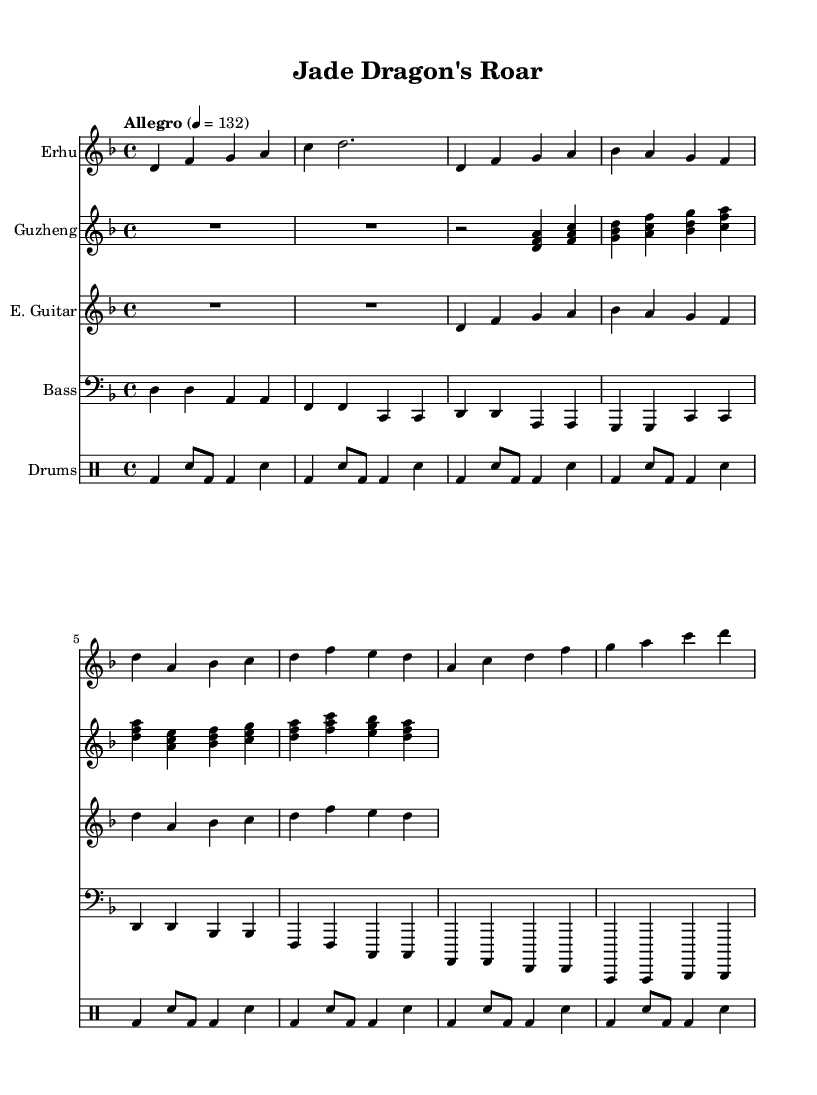What is the key signature of this music? The key signature is D minor, which has one flat (B flat). This can be determined by looking at the key signature indicated at the beginning of the score.
Answer: D minor What is the time signature of the piece? The time signature is 4/4, which is commonly noted at the beginning of the score indicating four beats per measure with a quarter note receiving one beat. This is found prominently in the initial section of the music.
Answer: 4/4 What is the tempo marking for the piece? The tempo marking is Allegro, which is indicated in the tempo indication at the start of the score, showing a fast and lively pace. The beats per minute is set at 132.
Answer: Allegro How many bars are present in the electric guitar section? In the electric guitar section, there are 8 bars, counted by noting each measure line and taking into account the rest measures as well.
Answer: 8 Which traditional Chinese instrument is featured throughout this score? The traditional Chinese instrument featured is the Erhu, which is specified at the start of its staff. Its role is significant in the arrangement, blending with modern rock elements.
Answer: Erhu What is the rhythmic pattern in the drum kit section? The rhythmic pattern in the drum kit section primarily features a consistent bass drum and snare variation, which is repeated across 8 bars. Each measure has a rhythmic pulse typically found in rock music, indicated by bass drum (bd) and snare (sn) notation.
Answer: Bass and snare What type of guitars are included in this composition? The score includes an electric guitar and a bass guitar, as specified in the individual instrument names on their respective staves. Each serves a distinct role, with electric guitar carrying melody and bass guitar providing harmonic support.
Answer: Electric guitar and bass guitar 